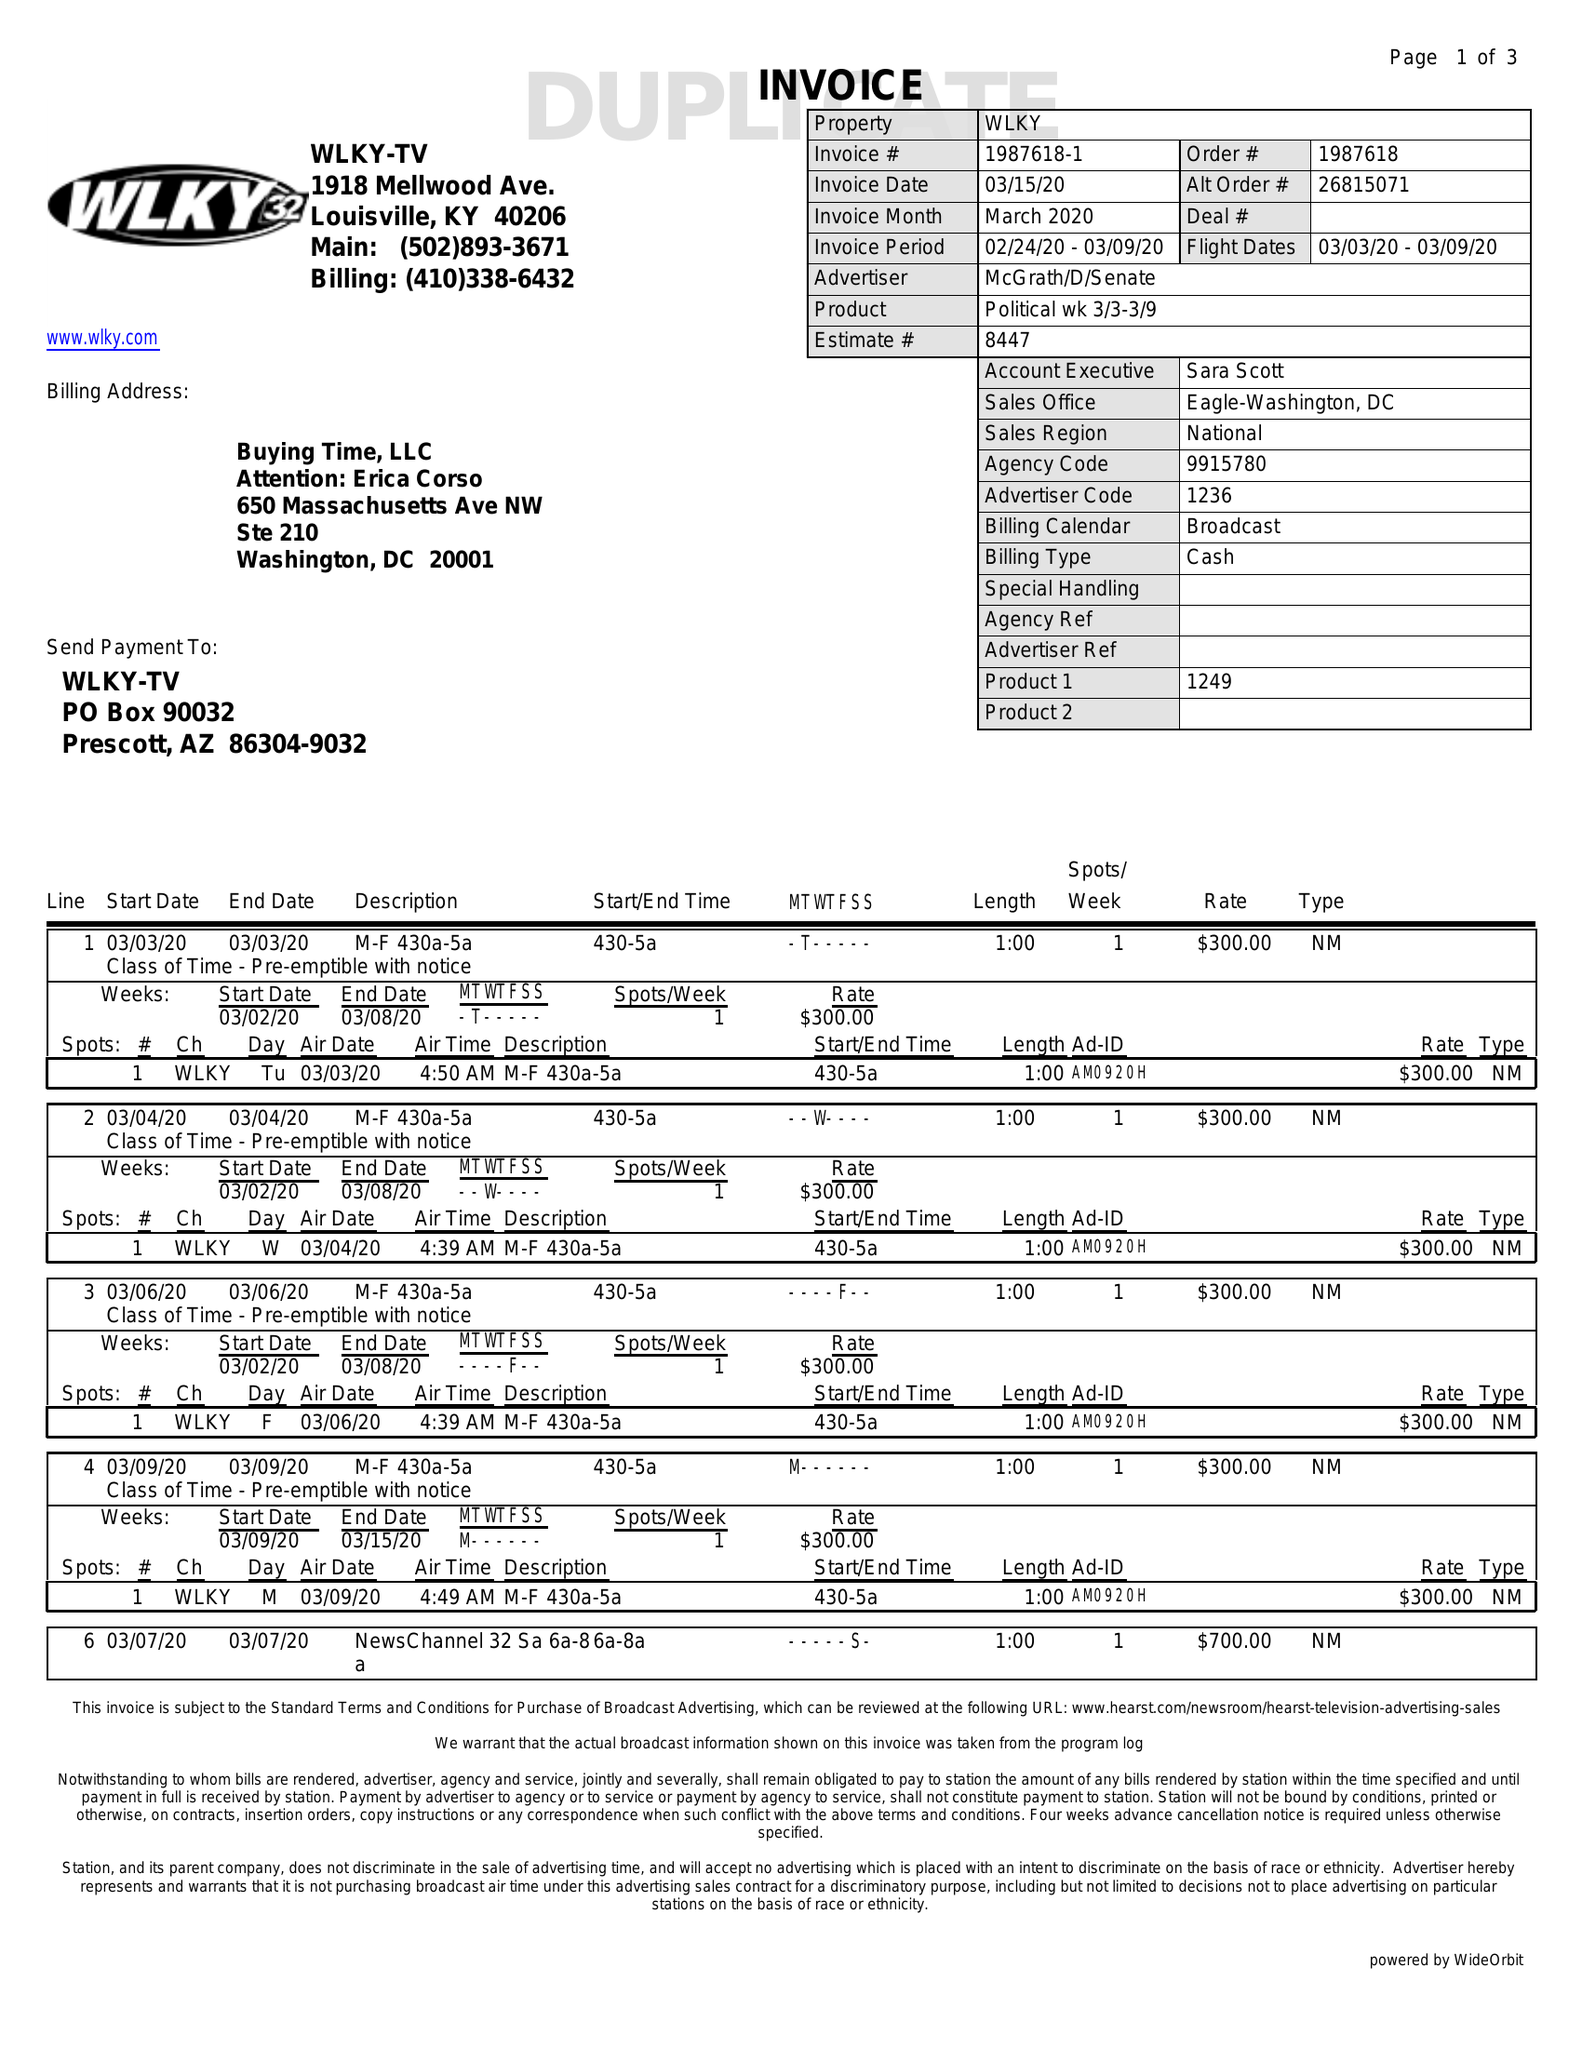What is the value for the gross_amount?
Answer the question using a single word or phrase. 11000.00 